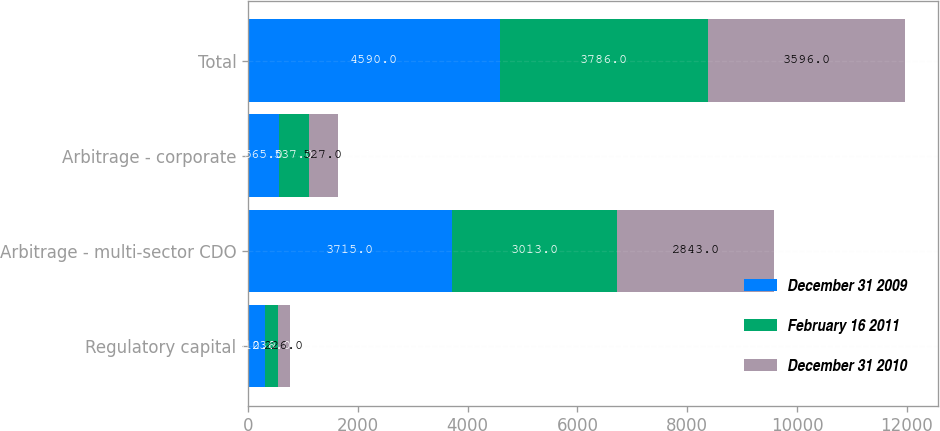<chart> <loc_0><loc_0><loc_500><loc_500><stacked_bar_chart><ecel><fcel>Regulatory capital<fcel>Arbitrage - multi-sector CDO<fcel>Arbitrage - corporate<fcel>Total<nl><fcel>December 31 2009<fcel>310<fcel>3715<fcel>565<fcel>4590<nl><fcel>February 16 2011<fcel>236<fcel>3013<fcel>537<fcel>3786<nl><fcel>December 31 2010<fcel>226<fcel>2843<fcel>527<fcel>3596<nl></chart> 